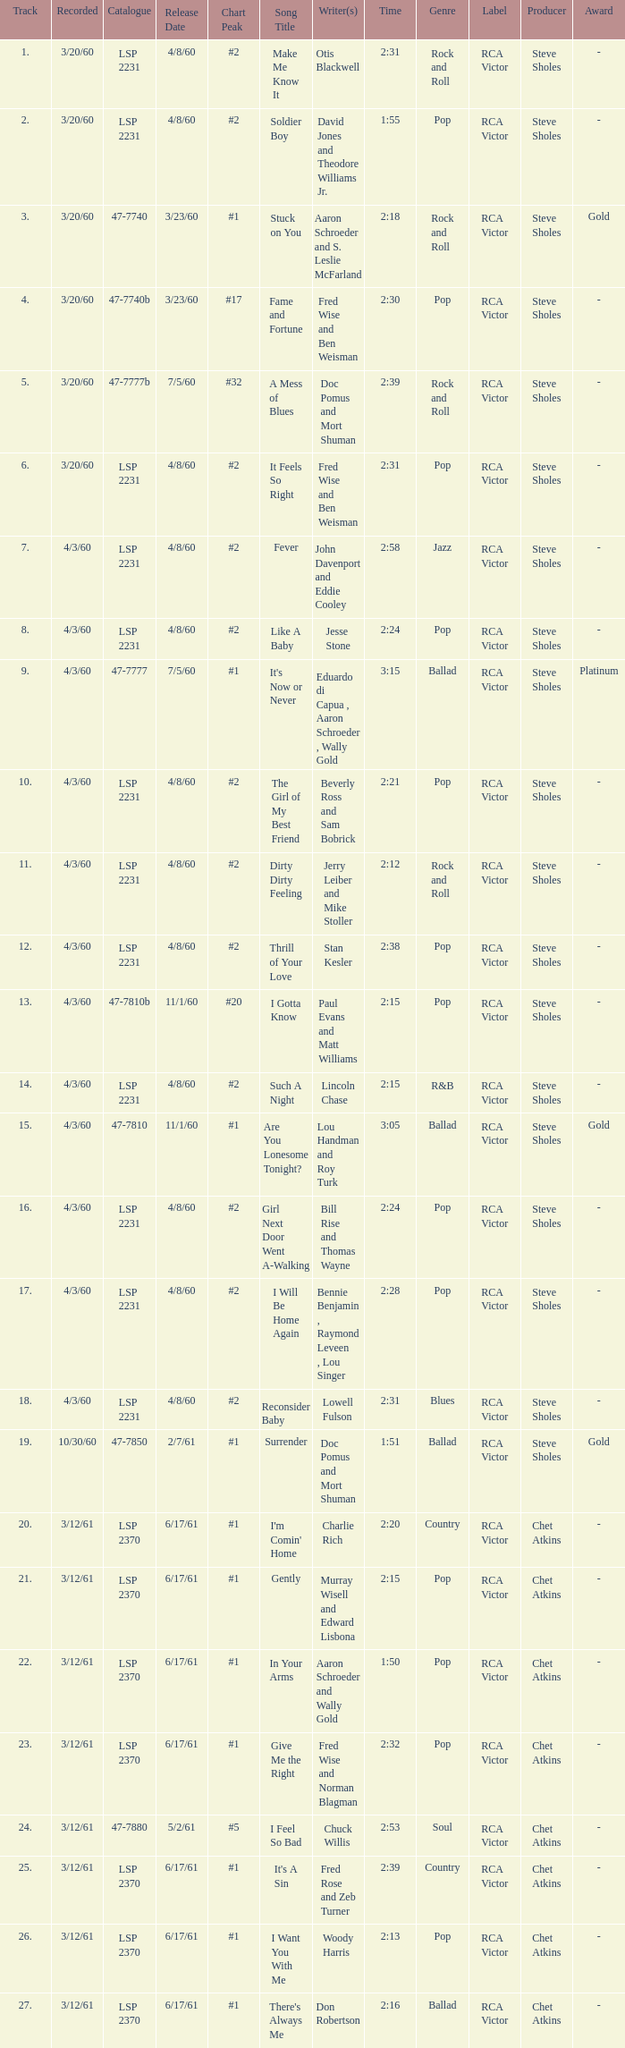On songs with track numbers smaller than number 17 and catalogues of LSP 2231, who are the writer(s)? Otis Blackwell, David Jones and Theodore Williams Jr., Fred Wise and Ben Weisman, John Davenport and Eddie Cooley, Jesse Stone, Beverly Ross and Sam Bobrick, Jerry Leiber and Mike Stoller, Stan Kesler, Lincoln Chase, Bill Rise and Thomas Wayne. 